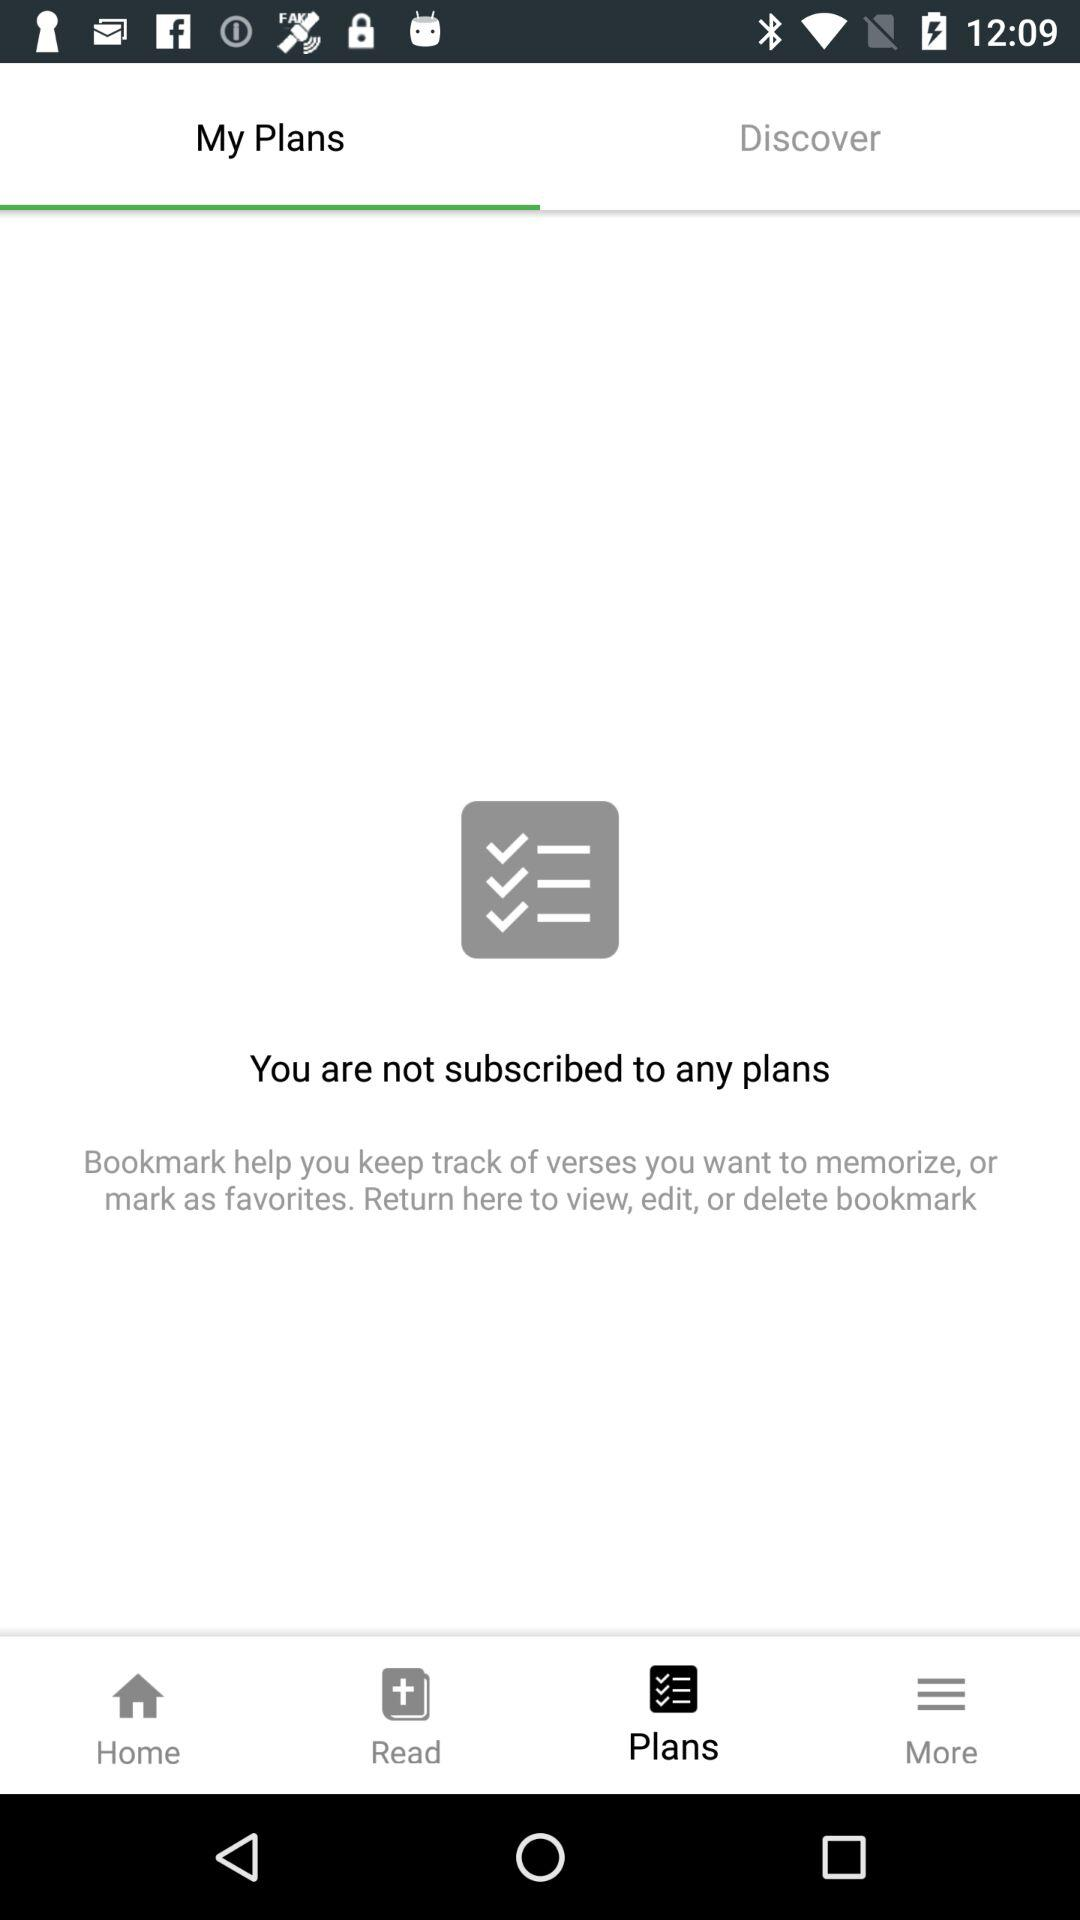How many plans do I have? 0 